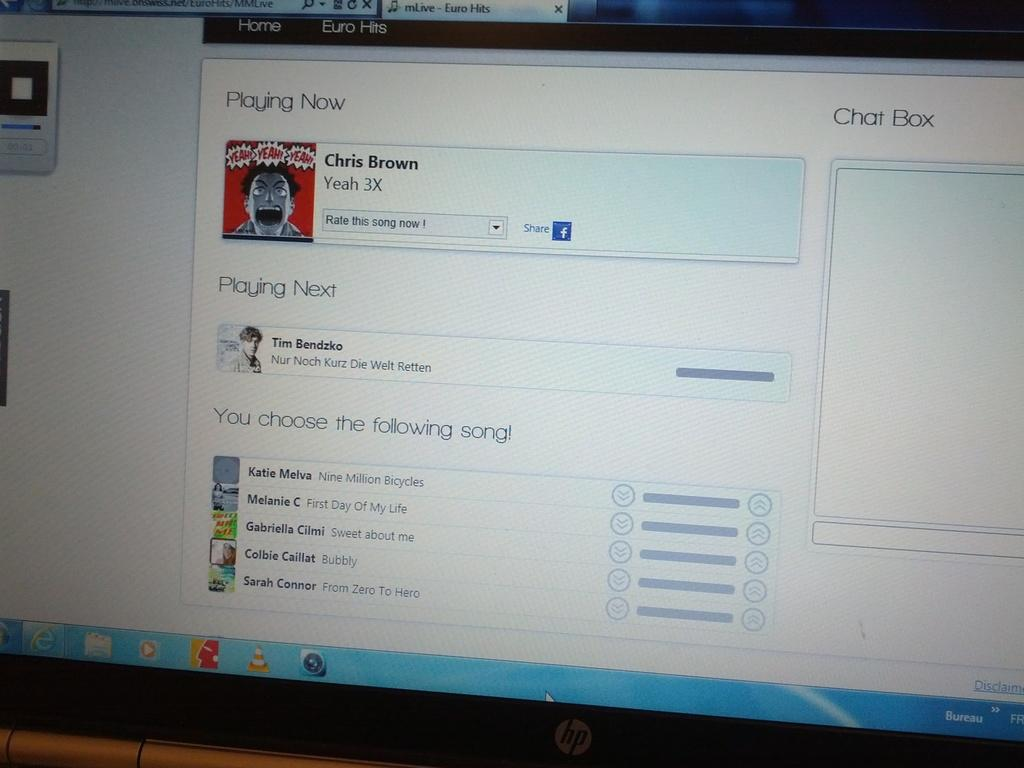<image>
Provide a brief description of the given image. An HP monitor shows a chat box and a facebook share button 